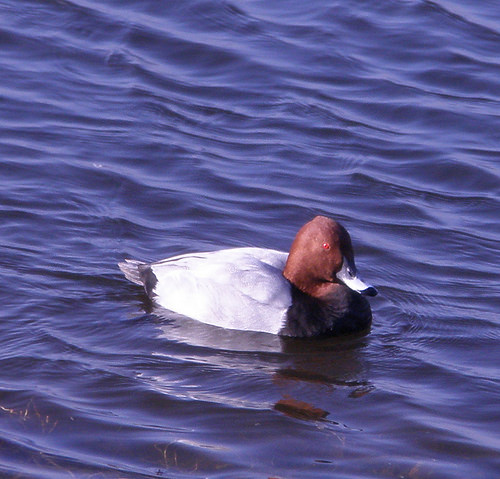<image>
Can you confirm if the duck is in the water? Yes. The duck is contained within or inside the water, showing a containment relationship. Where is the bird in relation to the water? Is it in front of the water? No. The bird is not in front of the water. The spatial positioning shows a different relationship between these objects. 